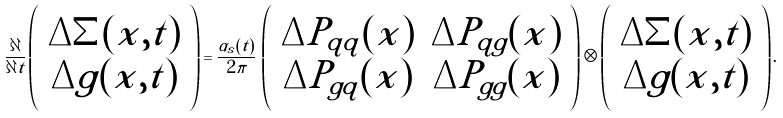<formula> <loc_0><loc_0><loc_500><loc_500>\frac { \partial } { \partial t } \left ( \begin{array} { c } \Delta \Sigma ( x , t ) \\ \Delta g ( x , t ) \end{array} \right ) = \frac { \alpha _ { s } ( t ) } { 2 \pi } \, \left ( \begin{array} { c c } \Delta P _ { q q } ( x ) & \Delta P _ { q g } ( x ) \\ \Delta P _ { g q } ( x ) & \Delta P _ { g g } ( x ) \\ \end{array} \right ) \otimes \left ( \begin{array} { c } \Delta \Sigma ( x , t ) \\ \Delta g ( x , t ) \end{array} \right ) .</formula> 